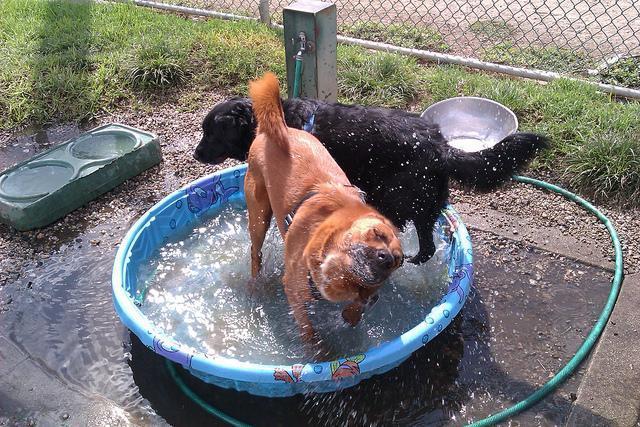How many dogs are in the picture?
Give a very brief answer. 3. 